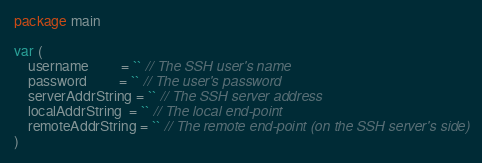<code> <loc_0><loc_0><loc_500><loc_500><_Go_>package main

var (
	username         = `` // The SSH user's name
	password         = `` // The user's password
	serverAddrString = `` // The SSH server address
	localAddrString  = `` // The local end-point
	remoteAddrString = `` // The remote end-point (on the SSH server's side)
)
</code> 